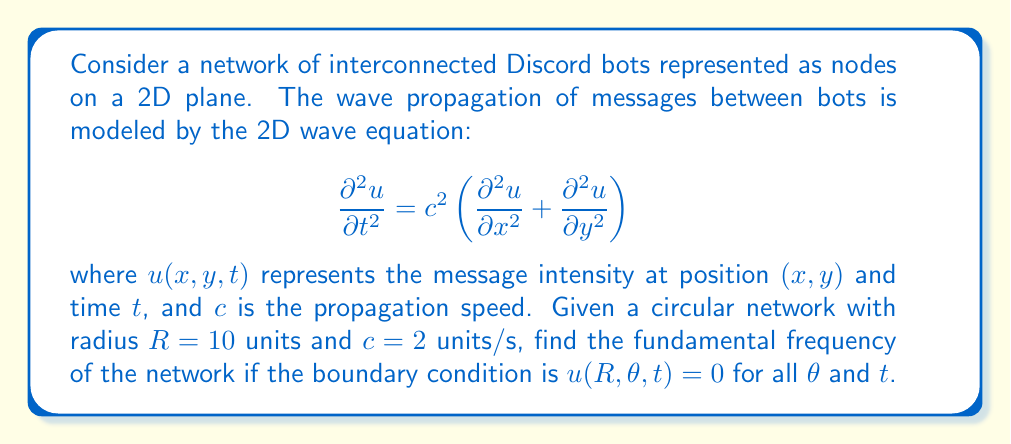Help me with this question. To solve this problem, we need to follow these steps:

1) First, we recognize that the problem has circular symmetry, so we should use polar coordinates $(r,\theta)$ instead of Cartesian coordinates $(x,y)$. The wave equation in polar coordinates is:

   $$\frac{\partial^2 u}{\partial t^2} = c^2 \left(\frac{\partial^2 u}{\partial r^2} + \frac{1}{r}\frac{\partial u}{\partial r} + \frac{1}{r^2}\frac{\partial^2 u}{\partial \theta^2}\right)$$

2) Due to the circular symmetry and the boundary condition, we can assume that the solution is independent of $\theta$. This simplifies our equation to:

   $$\frac{\partial^2 u}{\partial t^2} = c^2 \left(\frac{\partial^2 u}{\partial r^2} + \frac{1}{r}\frac{\partial u}{\partial r}\right)$$

3) We can separate variables by assuming a solution of the form $u(r,t) = R(r)T(t)$. Substituting this into our equation and dividing by $RT$, we get:

   $$\frac{1}{c^2}\frac{T''}{T} = \frac{R''}{R} + \frac{1}{r}\frac{R'}{R} = -k^2$$

   where $k$ is a separation constant.

4) The time part of this equation gives us $T(t) = A\cos(kct) + B\sin(kct)$, where the frequency is $f = \frac{kc}{2\pi}$.

5) The radial part of the equation is a Bessel equation:

   $$r^2R'' + rR' + k^2r^2R = 0$$

   The solution to this equation that is finite at $r=0$ is the Bessel function of the first kind, $J_0(kr)$.

6) The boundary condition $u(R,\theta,t) = 0$ implies $J_0(kR) = 0$. The smallest positive root of $J_0$ is approximately 2.4048.

7) Therefore, $kR = 2.4048$, or $k = \frac{2.4048}{R}$.

8) The fundamental frequency is thus:

   $$f = \frac{kc}{2\pi} = \frac{2.4048c}{2\pi R}$$

9) Substituting the given values $c=2$ and $R=10$:

   $$f = \frac{2.4048 \cdot 2}{2\pi \cdot 10} \approx 0.0765 \text{ Hz}$$
Answer: The fundamental frequency of the network is approximately 0.0765 Hz. 